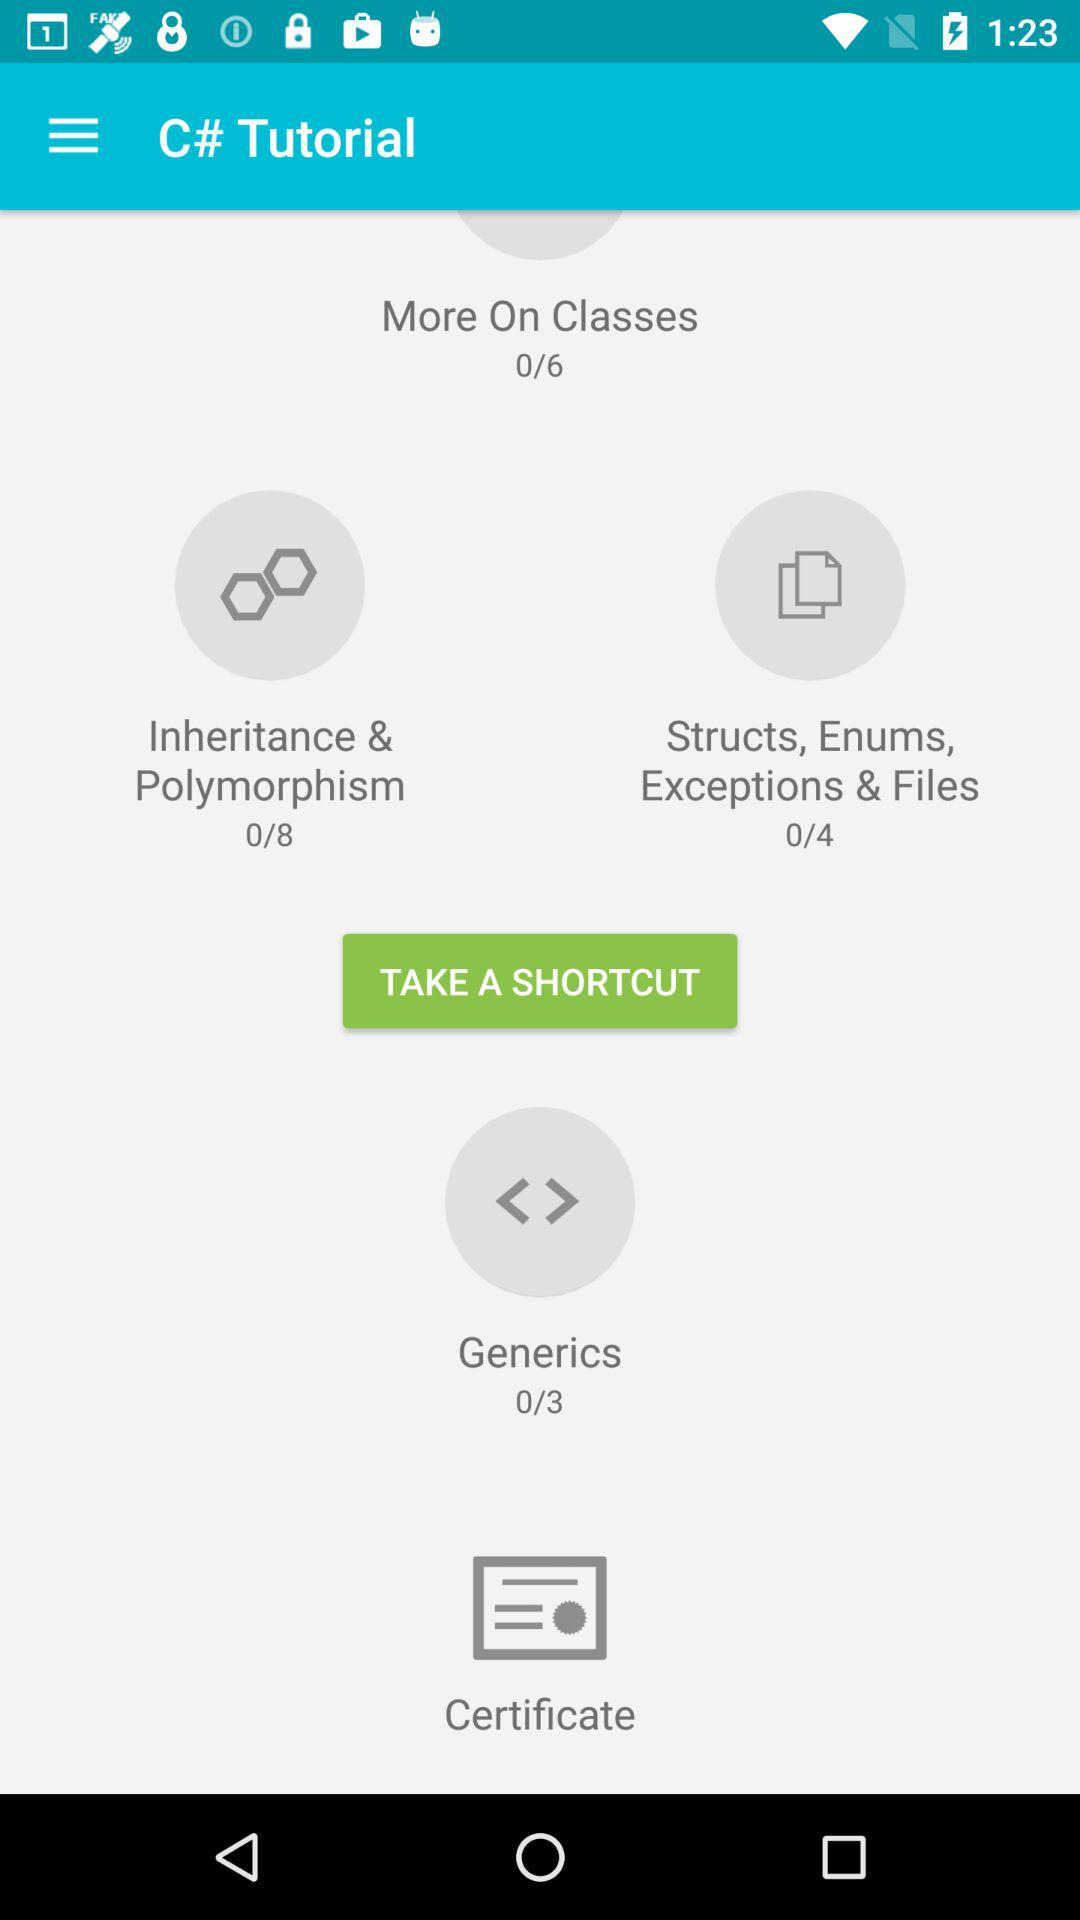What is the name of the chapter with 4 tutorials? The name of the chapter with 4 tutorials is "Structs, Enums, Exceptions & Files". 